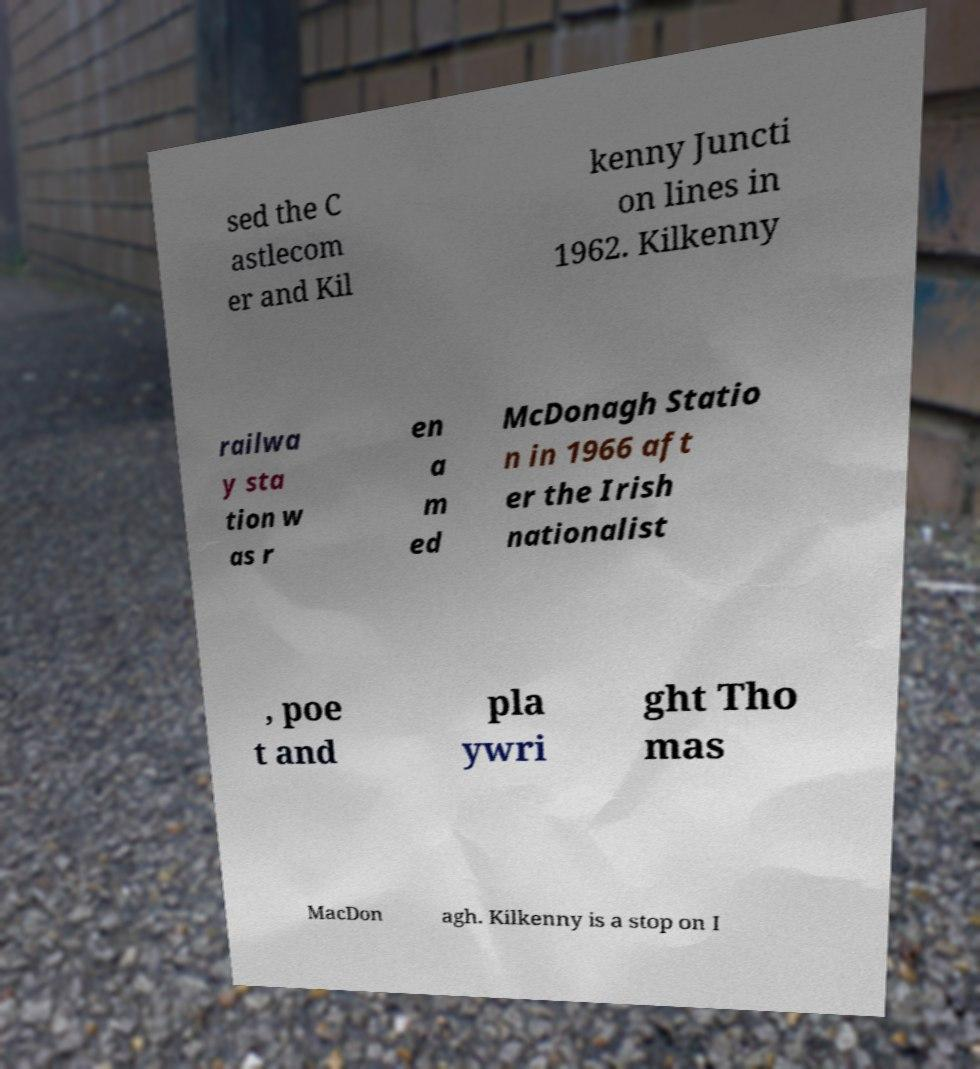For documentation purposes, I need the text within this image transcribed. Could you provide that? sed the C astlecom er and Kil kenny Juncti on lines in 1962. Kilkenny railwa y sta tion w as r en a m ed McDonagh Statio n in 1966 aft er the Irish nationalist , poe t and pla ywri ght Tho mas MacDon agh. Kilkenny is a stop on I 